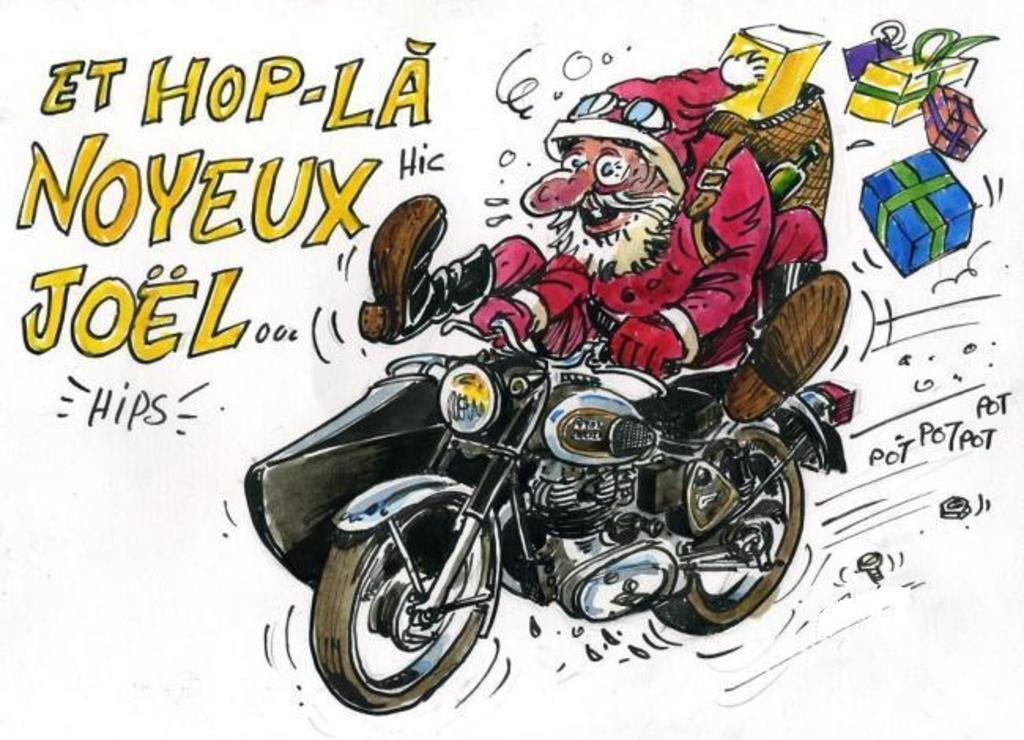Can you describe this image briefly? In this image there is a sketch of a cartoon with Santa riding the bike with gifts and there is some text on it. 